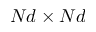Convert formula to latex. <formula><loc_0><loc_0><loc_500><loc_500>N d \times N d</formula> 